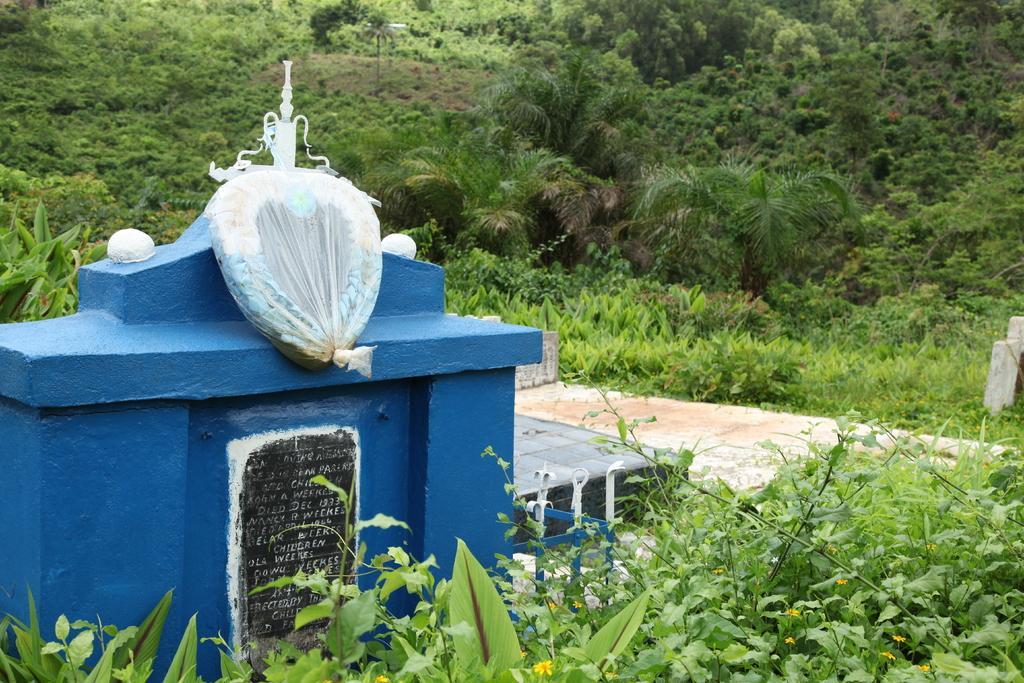In one or two sentences, can you explain what this image depicts? This picture shows a tomb and surrounded by trees and plants 